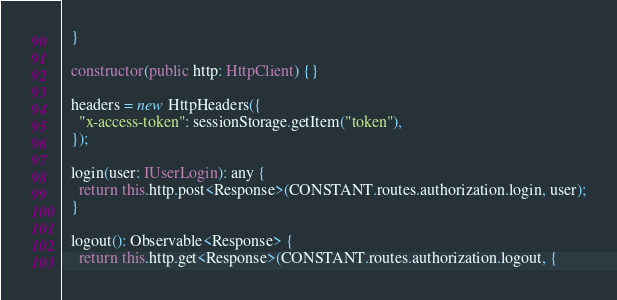<code> <loc_0><loc_0><loc_500><loc_500><_TypeScript_>  }

  constructor(public http: HttpClient) {}

  headers = new HttpHeaders({
    "x-access-token": sessionStorage.getItem("token"),
  });

  login(user: IUserLogin): any {
    return this.http.post<Response>(CONSTANT.routes.authorization.login, user);
  }

  logout(): Observable<Response> {
    return this.http.get<Response>(CONSTANT.routes.authorization.logout, {</code> 